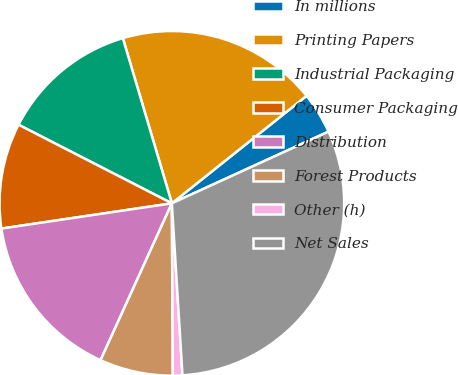Convert chart. <chart><loc_0><loc_0><loc_500><loc_500><pie_chart><fcel>In millions<fcel>Printing Papers<fcel>Industrial Packaging<fcel>Consumer Packaging<fcel>Distribution<fcel>Forest Products<fcel>Other (h)<fcel>Net Sales<nl><fcel>3.89%<fcel>18.87%<fcel>12.87%<fcel>9.88%<fcel>15.87%<fcel>6.88%<fcel>0.89%<fcel>30.85%<nl></chart> 